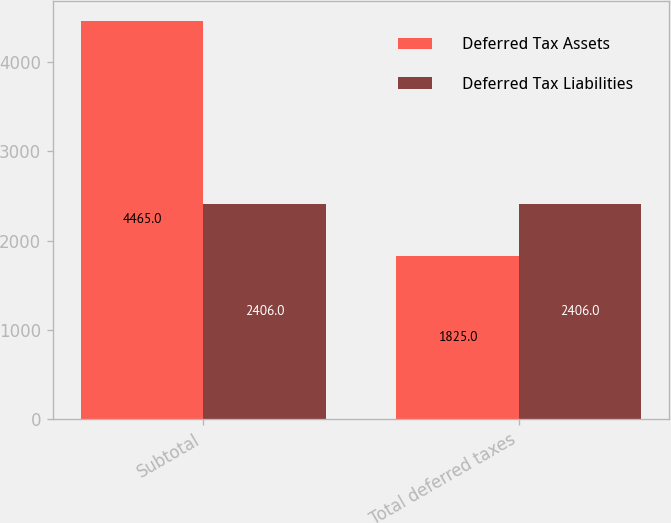<chart> <loc_0><loc_0><loc_500><loc_500><stacked_bar_chart><ecel><fcel>Subtotal<fcel>Total deferred taxes<nl><fcel>Deferred Tax Assets<fcel>4465<fcel>1825<nl><fcel>Deferred Tax Liabilities<fcel>2406<fcel>2406<nl></chart> 